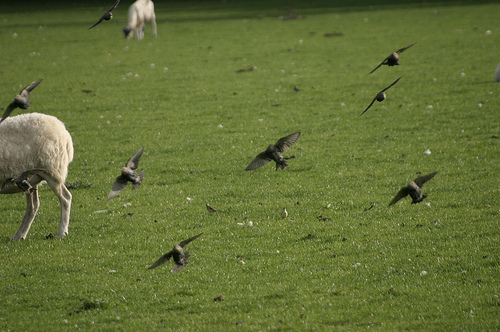Please provide the bounding box coordinate of the region this sentence describes: a small black bird in flight. The small black bird in flight covers a region approximately from [0.0, 0.32, 0.09, 0.41], flying to the left with its wings spread. 